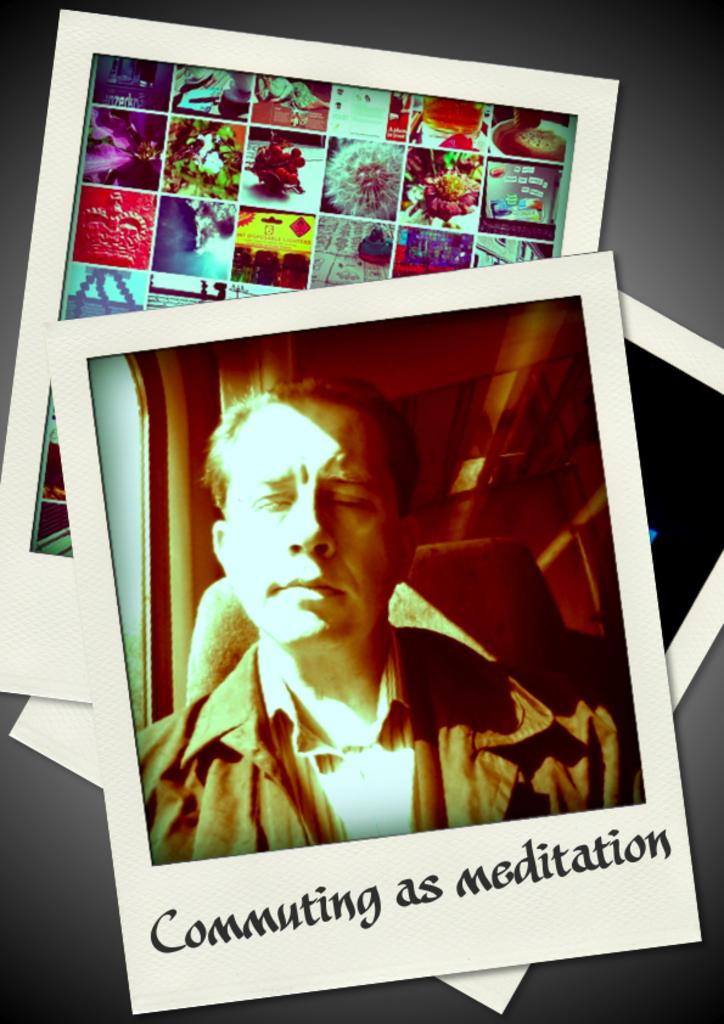What type of image is being described? The image is a collage. Has the image been altered in any way? Yes, the image has been edited. How many cents are visible in the image? There are no cents present in the image, as it is a collage and not a photograph of coins or currency. 